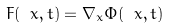Convert formula to latex. <formula><loc_0><loc_0><loc_500><loc_500>\ F ( \ x , t ) = \nabla _ { x } \Phi ( \ x , t )</formula> 